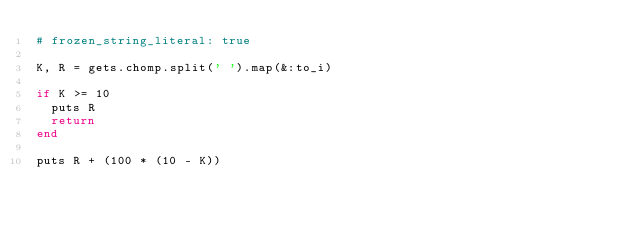Convert code to text. <code><loc_0><loc_0><loc_500><loc_500><_Ruby_># frozen_string_literal: true

K, R = gets.chomp.split(' ').map(&:to_i)

if K >= 10
  puts R
  return
end

puts R + (100 * (10 - K))
</code> 